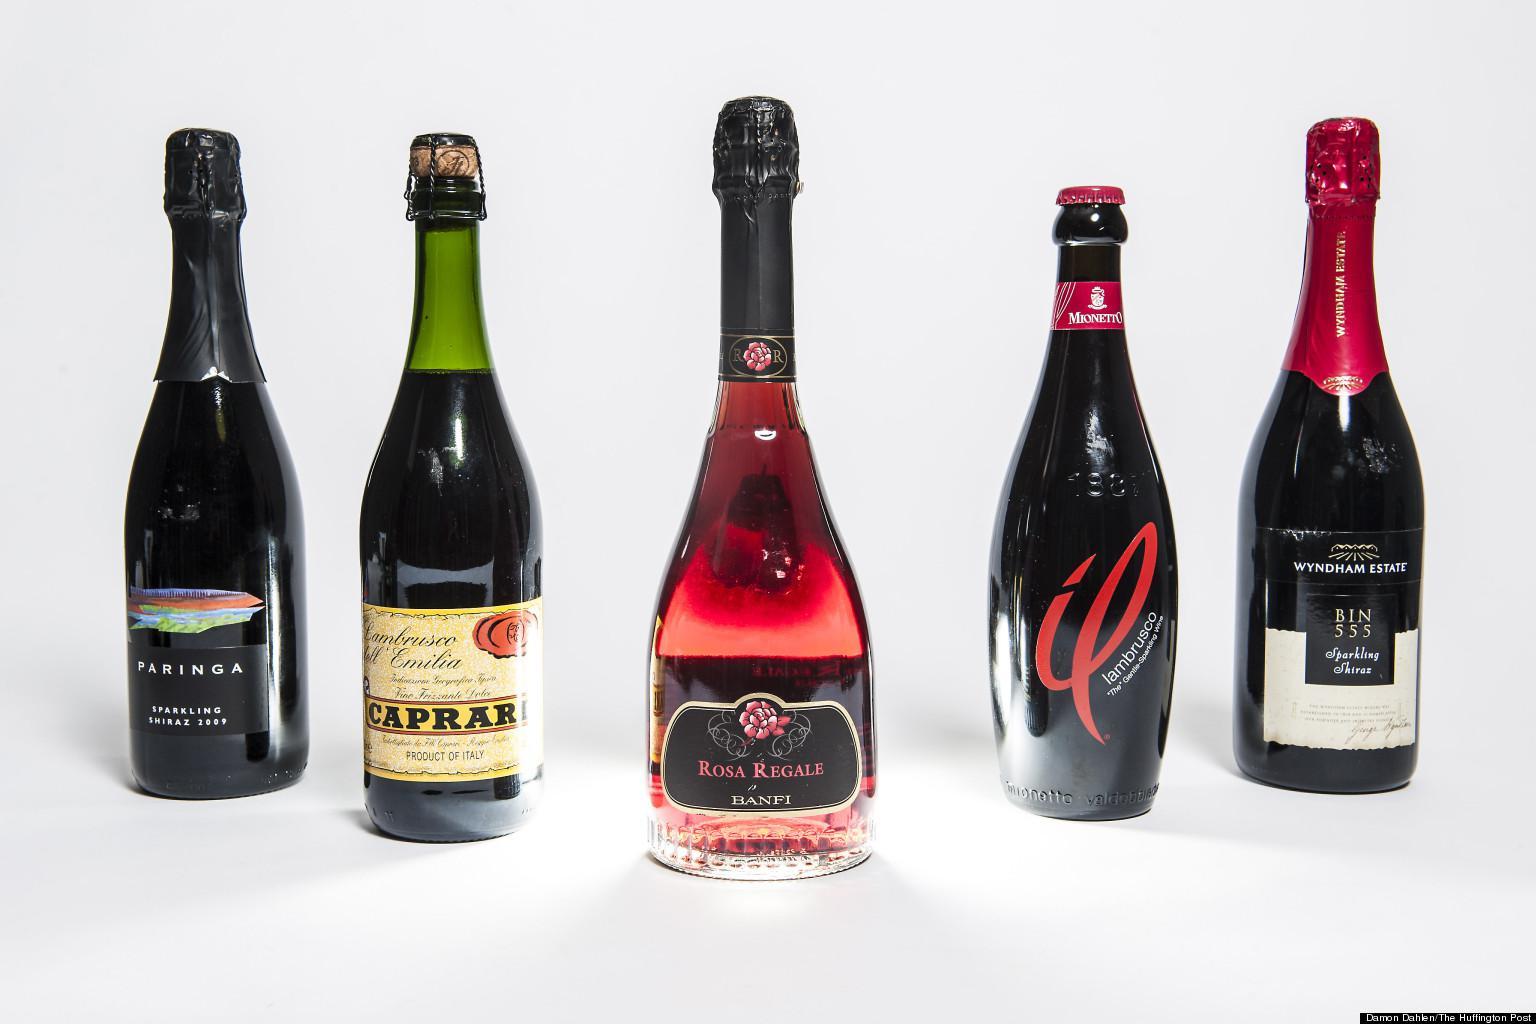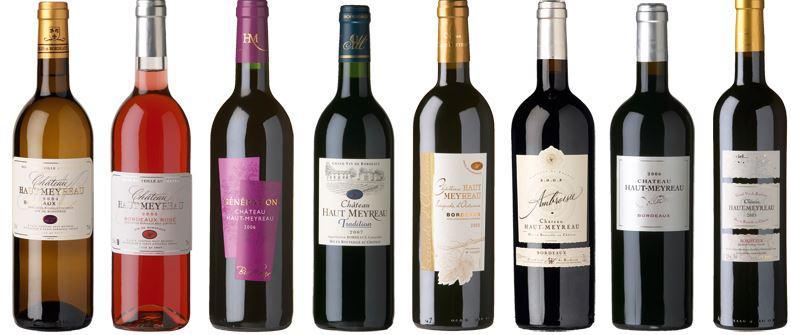The first image is the image on the left, the second image is the image on the right. Evaluate the accuracy of this statement regarding the images: "The image on the left has a bottle of red colored wine sitting in the center of a group of 5 wine bottles.". Is it true? Answer yes or no. Yes. The first image is the image on the left, the second image is the image on the right. Evaluate the accuracy of this statement regarding the images: "An image shows bottles arranged with the center one closest to the camera, and no bottles touching or identical.". Is it true? Answer yes or no. Yes. 